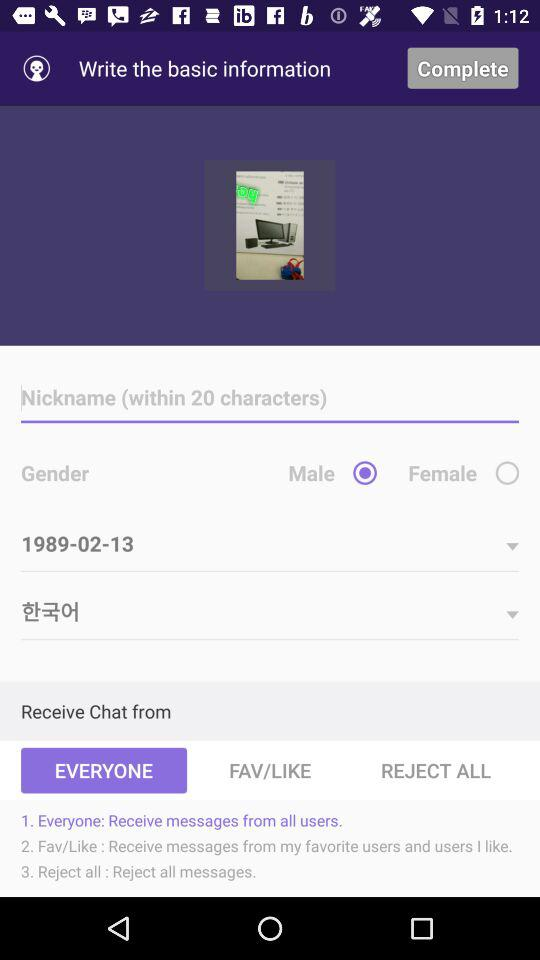What is the name of the application?
When the provided information is insufficient, respond with <no answer>. <no answer> 